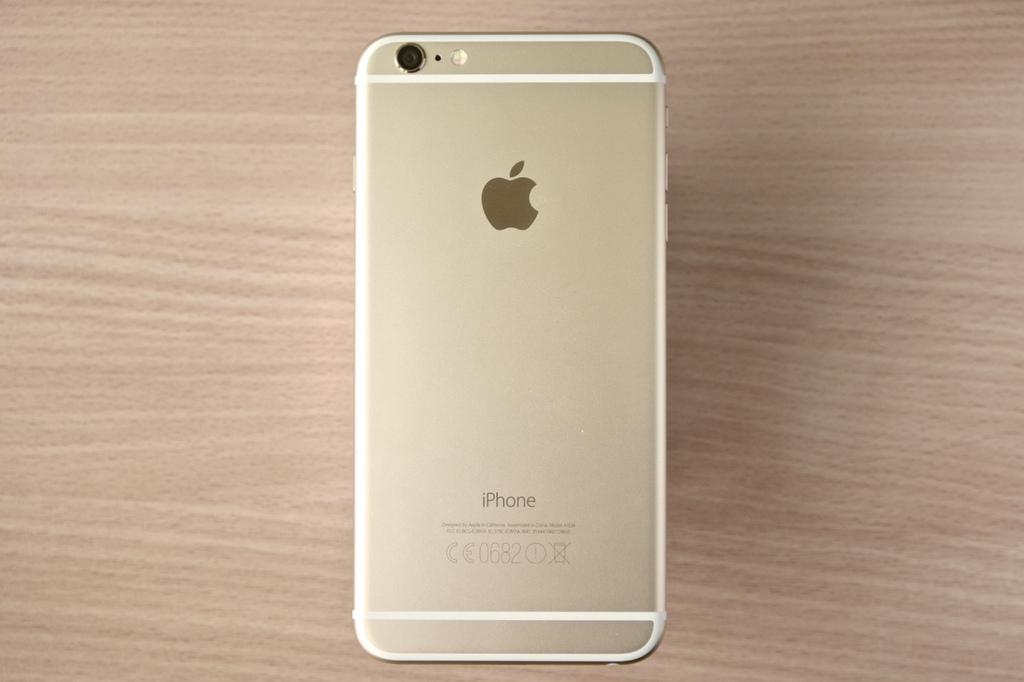What kind of smartphone is this?
Keep it short and to the point. Iphone. What is the model name of this phone?
Offer a very short reply. Iphone. 